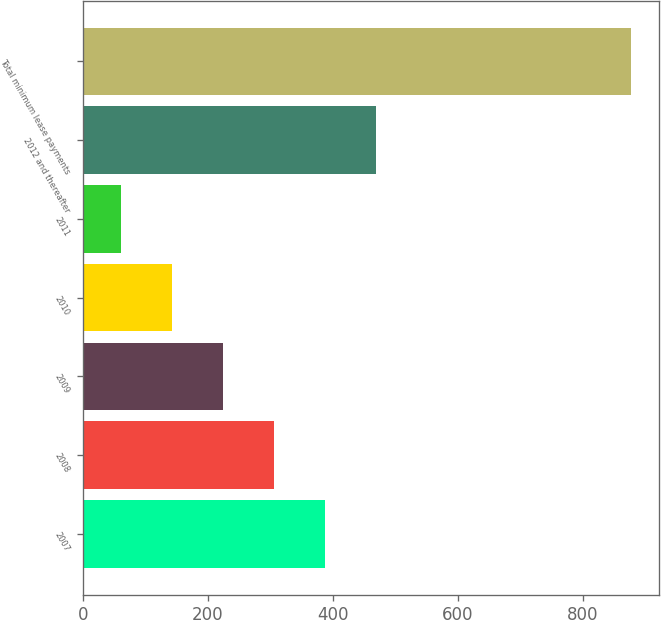Convert chart. <chart><loc_0><loc_0><loc_500><loc_500><bar_chart><fcel>2007<fcel>2008<fcel>2009<fcel>2010<fcel>2011<fcel>2012 and thereafter<fcel>Total minimum lease payments<nl><fcel>387.8<fcel>306.1<fcel>224.4<fcel>142.7<fcel>61<fcel>469.5<fcel>878<nl></chart> 